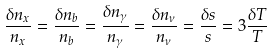<formula> <loc_0><loc_0><loc_500><loc_500>\frac { \delta n _ { x } } { n _ { x } } = \frac { \delta n _ { b } } { n _ { b } } = \frac { \delta n _ { \gamma } } { n _ { \gamma } } = \frac { \delta n _ { \nu } } { n _ { \nu } } = \frac { \delta s } { s } = 3 \frac { \delta T } { T }</formula> 